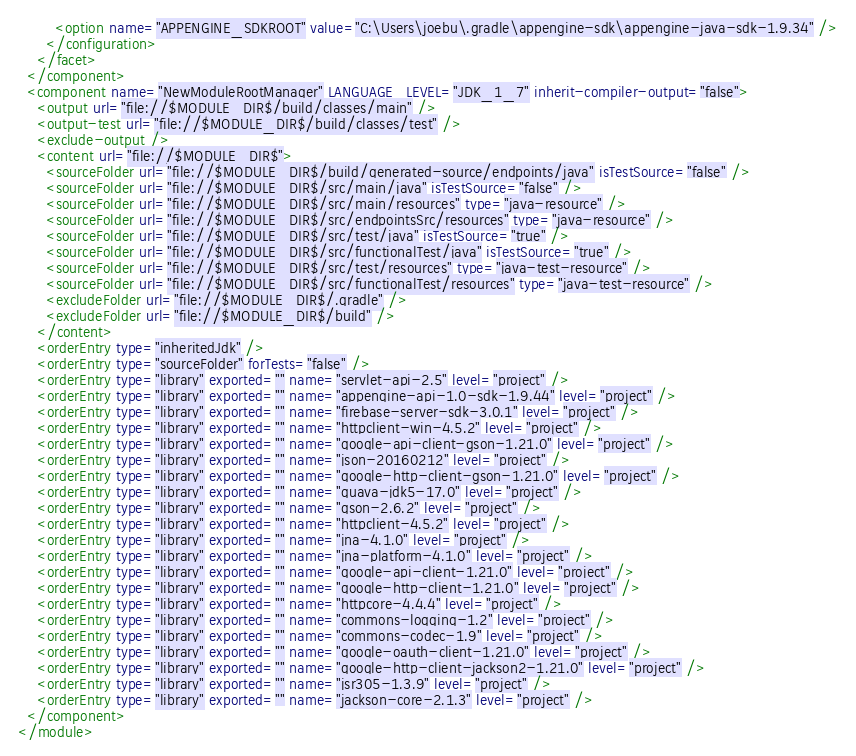<code> <loc_0><loc_0><loc_500><loc_500><_XML_>        <option name="APPENGINE_SDKROOT" value="C:\Users\joebu\.gradle\appengine-sdk\appengine-java-sdk-1.9.34" />
      </configuration>
    </facet>
  </component>
  <component name="NewModuleRootManager" LANGUAGE_LEVEL="JDK_1_7" inherit-compiler-output="false">
    <output url="file://$MODULE_DIR$/build/classes/main" />
    <output-test url="file://$MODULE_DIR$/build/classes/test" />
    <exclude-output />
    <content url="file://$MODULE_DIR$">
      <sourceFolder url="file://$MODULE_DIR$/build/generated-source/endpoints/java" isTestSource="false" />
      <sourceFolder url="file://$MODULE_DIR$/src/main/java" isTestSource="false" />
      <sourceFolder url="file://$MODULE_DIR$/src/main/resources" type="java-resource" />
      <sourceFolder url="file://$MODULE_DIR$/src/endpointsSrc/resources" type="java-resource" />
      <sourceFolder url="file://$MODULE_DIR$/src/test/java" isTestSource="true" />
      <sourceFolder url="file://$MODULE_DIR$/src/functionalTest/java" isTestSource="true" />
      <sourceFolder url="file://$MODULE_DIR$/src/test/resources" type="java-test-resource" />
      <sourceFolder url="file://$MODULE_DIR$/src/functionalTest/resources" type="java-test-resource" />
      <excludeFolder url="file://$MODULE_DIR$/.gradle" />
      <excludeFolder url="file://$MODULE_DIR$/build" />
    </content>
    <orderEntry type="inheritedJdk" />
    <orderEntry type="sourceFolder" forTests="false" />
    <orderEntry type="library" exported="" name="servlet-api-2.5" level="project" />
    <orderEntry type="library" exported="" name="appengine-api-1.0-sdk-1.9.44" level="project" />
    <orderEntry type="library" exported="" name="firebase-server-sdk-3.0.1" level="project" />
    <orderEntry type="library" exported="" name="httpclient-win-4.5.2" level="project" />
    <orderEntry type="library" exported="" name="google-api-client-gson-1.21.0" level="project" />
    <orderEntry type="library" exported="" name="json-20160212" level="project" />
    <orderEntry type="library" exported="" name="google-http-client-gson-1.21.0" level="project" />
    <orderEntry type="library" exported="" name="guava-jdk5-17.0" level="project" />
    <orderEntry type="library" exported="" name="gson-2.6.2" level="project" />
    <orderEntry type="library" exported="" name="httpclient-4.5.2" level="project" />
    <orderEntry type="library" exported="" name="jna-4.1.0" level="project" />
    <orderEntry type="library" exported="" name="jna-platform-4.1.0" level="project" />
    <orderEntry type="library" exported="" name="google-api-client-1.21.0" level="project" />
    <orderEntry type="library" exported="" name="google-http-client-1.21.0" level="project" />
    <orderEntry type="library" exported="" name="httpcore-4.4.4" level="project" />
    <orderEntry type="library" exported="" name="commons-logging-1.2" level="project" />
    <orderEntry type="library" exported="" name="commons-codec-1.9" level="project" />
    <orderEntry type="library" exported="" name="google-oauth-client-1.21.0" level="project" />
    <orderEntry type="library" exported="" name="google-http-client-jackson2-1.21.0" level="project" />
    <orderEntry type="library" exported="" name="jsr305-1.3.9" level="project" />
    <orderEntry type="library" exported="" name="jackson-core-2.1.3" level="project" />
  </component>
</module></code> 